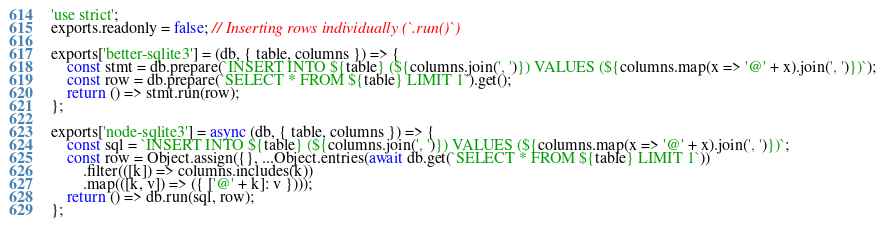<code> <loc_0><loc_0><loc_500><loc_500><_JavaScript_>'use strict';
exports.readonly = false; // Inserting rows individually (`.run()`)

exports['better-sqlite3'] = (db, { table, columns }) => {
	const stmt = db.prepare(`INSERT INTO ${table} (${columns.join(', ')}) VALUES (${columns.map(x => '@' + x).join(', ')})`);
	const row = db.prepare(`SELECT * FROM ${table} LIMIT 1`).get();
	return () => stmt.run(row);
};

exports['node-sqlite3'] = async (db, { table, columns }) => {
	const sql = `INSERT INTO ${table} (${columns.join(', ')}) VALUES (${columns.map(x => '@' + x).join(', ')})`;
	const row = Object.assign({}, ...Object.entries(await db.get(`SELECT * FROM ${table} LIMIT 1`))
		.filter(([k]) => columns.includes(k))
		.map(([k, v]) => ({ ['@' + k]: v })));
	return () => db.run(sql, row);
};
</code> 